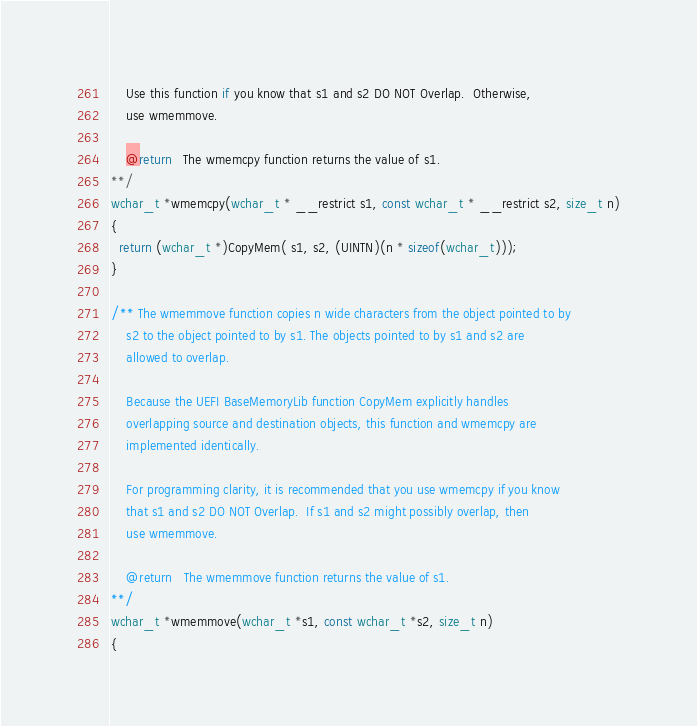<code> <loc_0><loc_0><loc_500><loc_500><_C_>
    Use this function if you know that s1 and s2 DO NOT Overlap.  Otherwise,
    use wmemmove.

    @return   The wmemcpy function returns the value of s1.
**/
wchar_t *wmemcpy(wchar_t * __restrict s1, const wchar_t * __restrict s2, size_t n)
{
  return (wchar_t *)CopyMem( s1, s2, (UINTN)(n * sizeof(wchar_t)));
}

/** The wmemmove function copies n wide characters from the object pointed to by
    s2 to the object pointed to by s1. The objects pointed to by s1 and s2 are
    allowed to overlap.

    Because the UEFI BaseMemoryLib function CopyMem explicitly handles
    overlapping source and destination objects, this function and wmemcpy are
    implemented identically.

    For programming clarity, it is recommended that you use wmemcpy if you know
    that s1 and s2 DO NOT Overlap.  If s1 and s2 might possibly overlap, then
    use wmemmove.

    @return   The wmemmove function returns the value of s1.
**/
wchar_t *wmemmove(wchar_t *s1, const wchar_t *s2, size_t n)
{</code> 